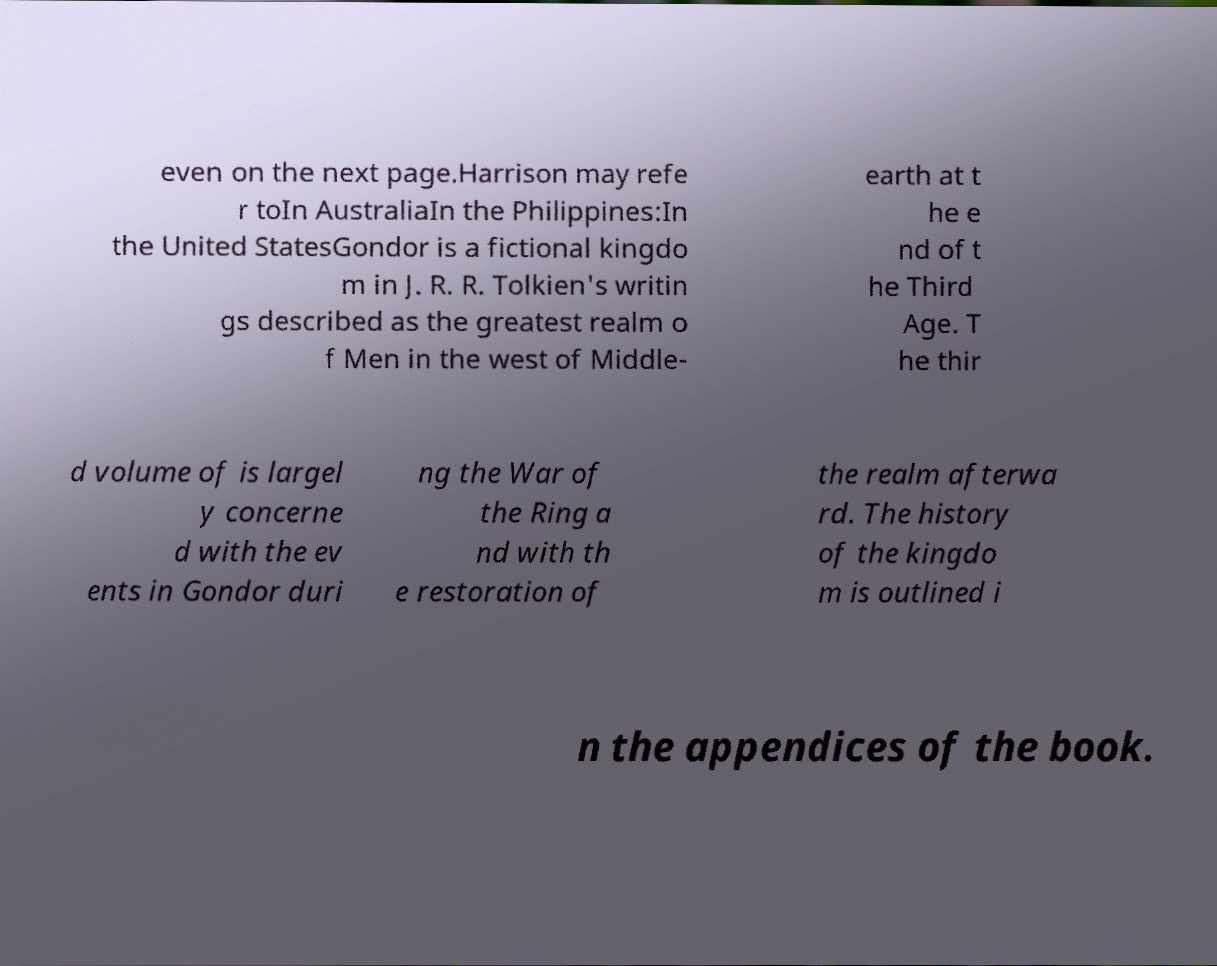I need the written content from this picture converted into text. Can you do that? even on the next page.Harrison may refe r toIn AustraliaIn the Philippines:In the United StatesGondor is a fictional kingdo m in J. R. R. Tolkien's writin gs described as the greatest realm o f Men in the west of Middle- earth at t he e nd of t he Third Age. T he thir d volume of is largel y concerne d with the ev ents in Gondor duri ng the War of the Ring a nd with th e restoration of the realm afterwa rd. The history of the kingdo m is outlined i n the appendices of the book. 